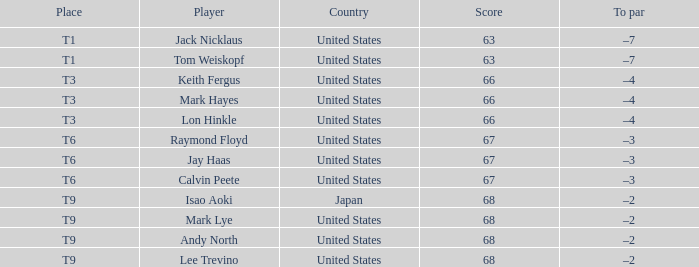What is the location, when the nation is "united states", and when the athlete is "lee trevino"? T9. 